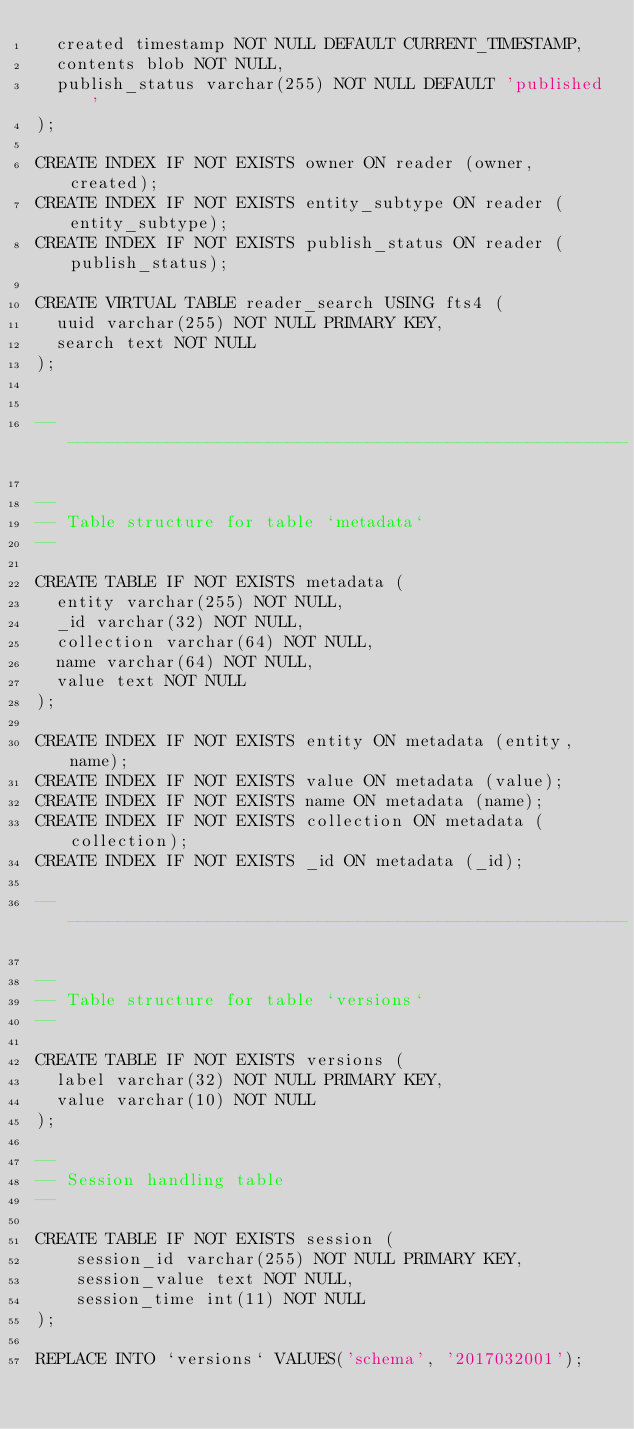<code> <loc_0><loc_0><loc_500><loc_500><_SQL_>  created timestamp NOT NULL DEFAULT CURRENT_TIMESTAMP,
  contents blob NOT NULL,
  publish_status varchar(255) NOT NULL DEFAULT 'published'
);

CREATE INDEX IF NOT EXISTS owner ON reader (owner, created);
CREATE INDEX IF NOT EXISTS entity_subtype ON reader (entity_subtype);
CREATE INDEX IF NOT EXISTS publish_status ON reader (publish_status);

CREATE VIRTUAL TABLE reader_search USING fts4 (
  uuid varchar(255) NOT NULL PRIMARY KEY,
  search text NOT NULL
);


-- --------------------------------------------------------

--
-- Table structure for table `metadata`
--

CREATE TABLE IF NOT EXISTS metadata (
  entity varchar(255) NOT NULL,
  _id varchar(32) NOT NULL,
  collection varchar(64) NOT NULL,
  name varchar(64) NOT NULL,
  value text NOT NULL
);

CREATE INDEX IF NOT EXISTS entity ON metadata (entity,name);
CREATE INDEX IF NOT EXISTS value ON metadata (value);
CREATE INDEX IF NOT EXISTS name ON metadata (name);
CREATE INDEX IF NOT EXISTS collection ON metadata (collection);
CREATE INDEX IF NOT EXISTS _id ON metadata (_id);

-- --------------------------------------------------------

--
-- Table structure for table `versions`
--

CREATE TABLE IF NOT EXISTS versions (
  label varchar(32) NOT NULL PRIMARY KEY,
  value varchar(10) NOT NULL
);

--
-- Session handling table
--

CREATE TABLE IF NOT EXISTS session (
    session_id varchar(255) NOT NULL PRIMARY KEY,
    session_value text NOT NULL,
    session_time int(11) NOT NULL
);

REPLACE INTO `versions` VALUES('schema', '2017032001');
</code> 